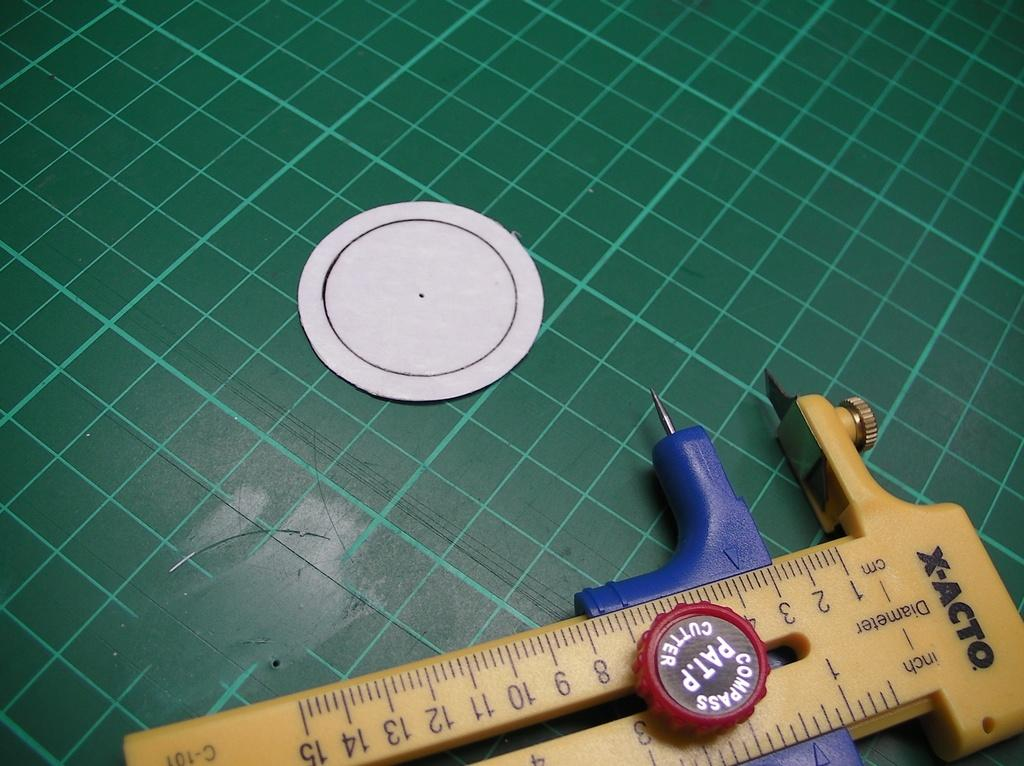<image>
Summarize the visual content of the image. A yellow Xacto branded measuring device is sitting on a green surface. 